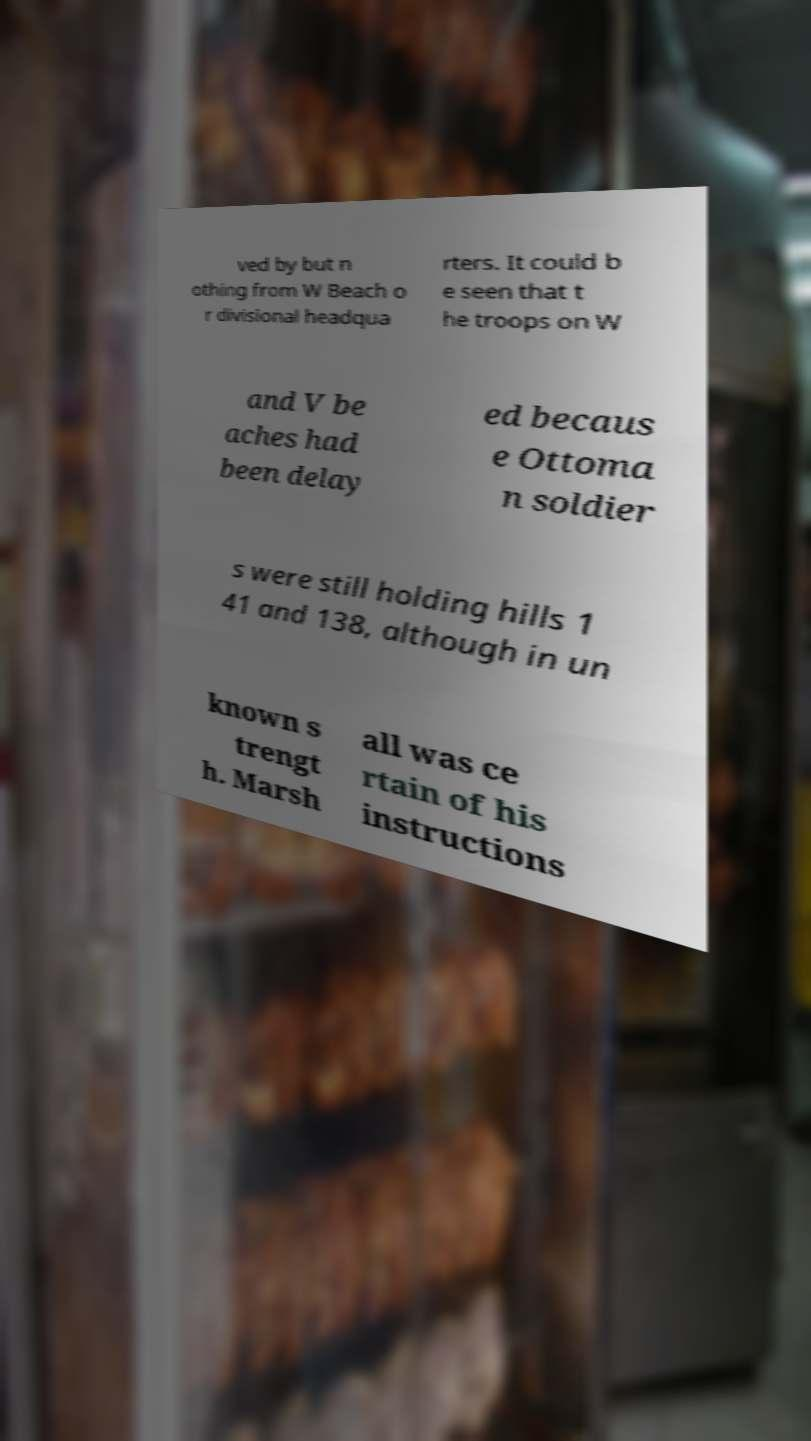Please read and relay the text visible in this image. What does it say? ved by but n othing from W Beach o r divisional headqua rters. It could b e seen that t he troops on W and V be aches had been delay ed becaus e Ottoma n soldier s were still holding hills 1 41 and 138, although in un known s trengt h. Marsh all was ce rtain of his instructions 